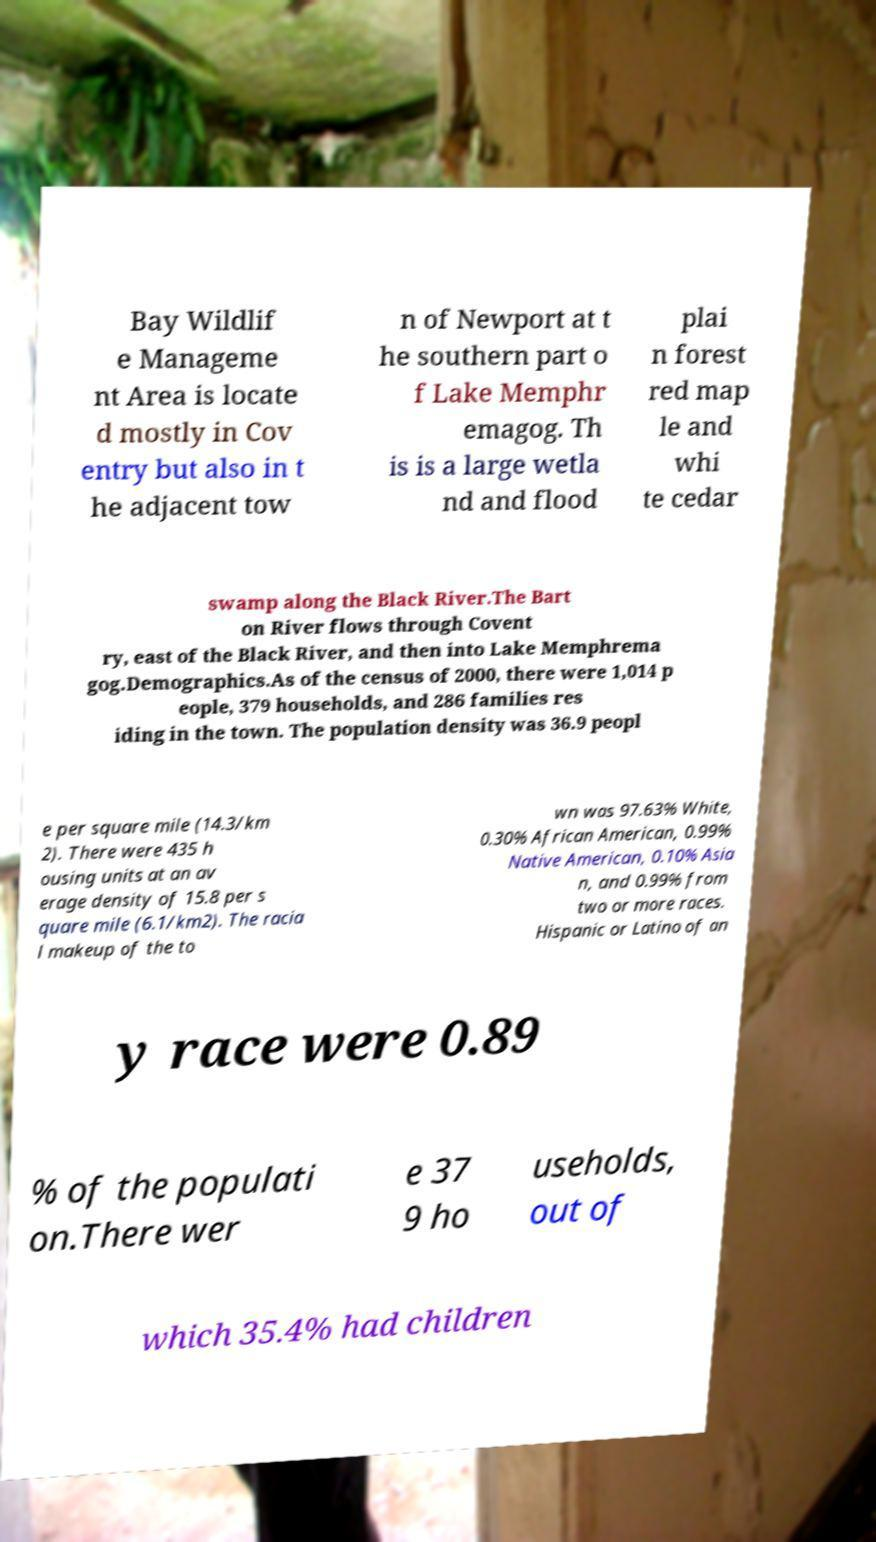There's text embedded in this image that I need extracted. Can you transcribe it verbatim? Bay Wildlif e Manageme nt Area is locate d mostly in Cov entry but also in t he adjacent tow n of Newport at t he southern part o f Lake Memphr emagog. Th is is a large wetla nd and flood plai n forest red map le and whi te cedar swamp along the Black River.The Bart on River flows through Covent ry, east of the Black River, and then into Lake Memphrema gog.Demographics.As of the census of 2000, there were 1,014 p eople, 379 households, and 286 families res iding in the town. The population density was 36.9 peopl e per square mile (14.3/km 2). There were 435 h ousing units at an av erage density of 15.8 per s quare mile (6.1/km2). The racia l makeup of the to wn was 97.63% White, 0.30% African American, 0.99% Native American, 0.10% Asia n, and 0.99% from two or more races. Hispanic or Latino of an y race were 0.89 % of the populati on.There wer e 37 9 ho useholds, out of which 35.4% had children 